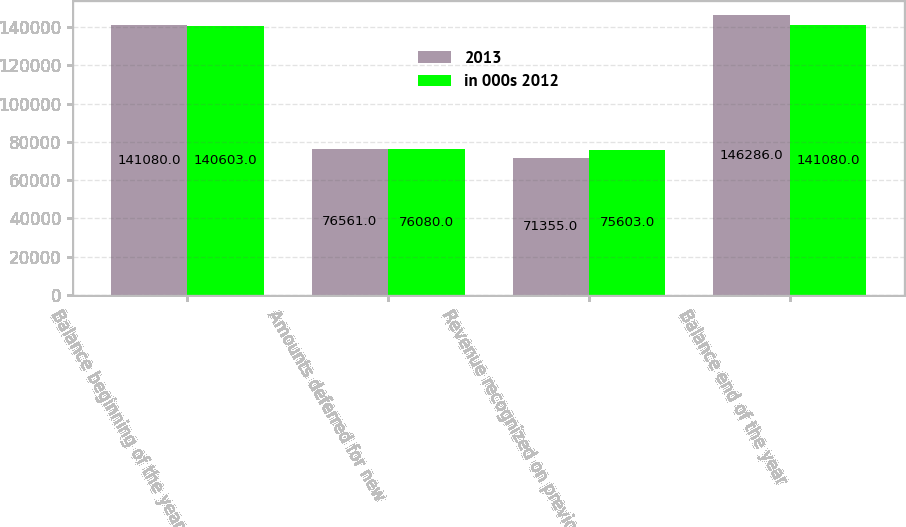Convert chart. <chart><loc_0><loc_0><loc_500><loc_500><stacked_bar_chart><ecel><fcel>Balance beginning of the year<fcel>Amounts deferred for new<fcel>Revenue recognized on previous<fcel>Balance end of the year<nl><fcel>2013<fcel>141080<fcel>76561<fcel>71355<fcel>146286<nl><fcel>in 000s 2012<fcel>140603<fcel>76080<fcel>75603<fcel>141080<nl></chart> 